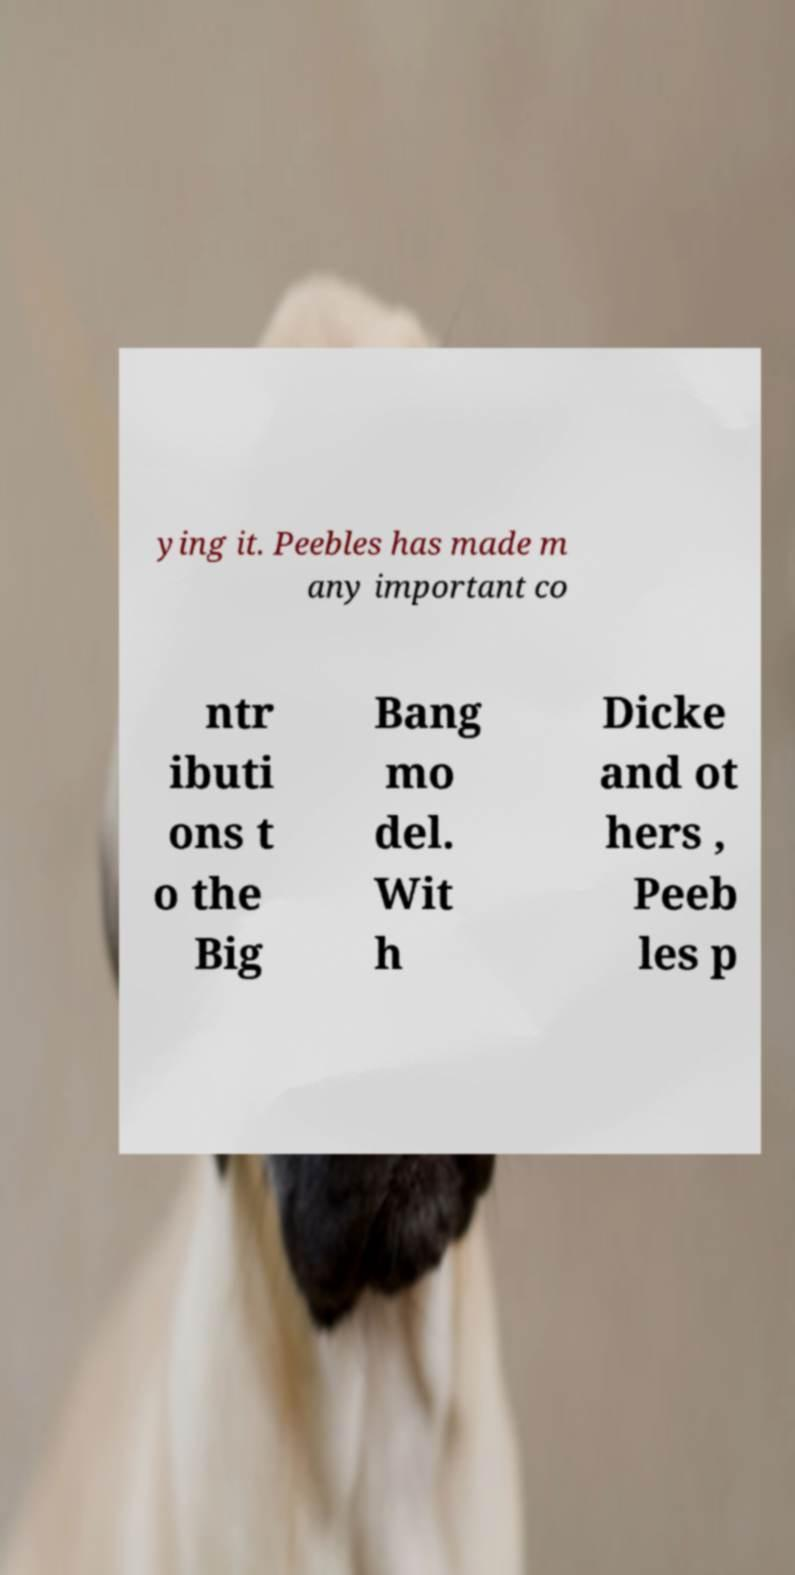Please identify and transcribe the text found in this image. ying it. Peebles has made m any important co ntr ibuti ons t o the Big Bang mo del. Wit h Dicke and ot hers , Peeb les p 